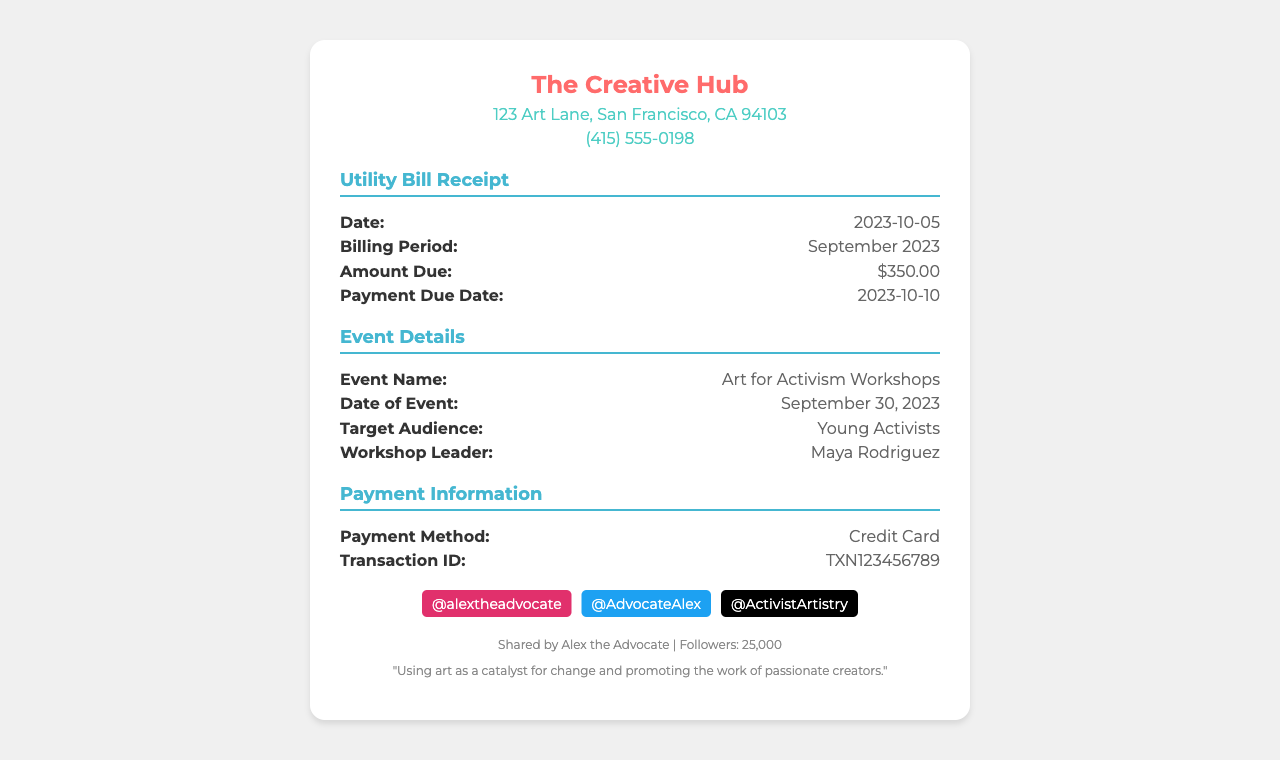What is the date of the receipt? The receipt date is explicitly stated in the document under "Date:", which is 2023-10-05.
Answer: 2023-10-05 What is the amount due for the utility bill? The amount due is mentioned under "Amount Due:" in the utility bill section, which is $350.00.
Answer: $350.00 What is the billing period covered by this receipt? The billing period is specified in the document as "September 2023."
Answer: September 2023 Who is the workshop leader for the event? The workshop leader's name is noted under "Workshop Leader:" in the event details section, identified as Maya Rodriguez.
Answer: Maya Rodriguez What is the payment method used for this bill? The payment method is clearly stated in the document under "Payment Method:" as Credit Card.
Answer: Credit Card What is the transaction ID for the payment? The transaction ID can be found in the payment information section labeled as "Transaction ID:" which is TXN123456789.
Answer: TXN123456789 What type of events are hosted in this co-working space? The document specifies that the event type is "Art for Activism Workshops" under the event details section.
Answer: Art for Activism Workshops When is the payment due? The payment due date is indicated under "Payment Due Date:" as 2023-10-10.
Answer: 2023-10-10 Who is the target audience for the workshop? The target audience is mentioned in the event details as "Young Activists."
Answer: Young Activists 